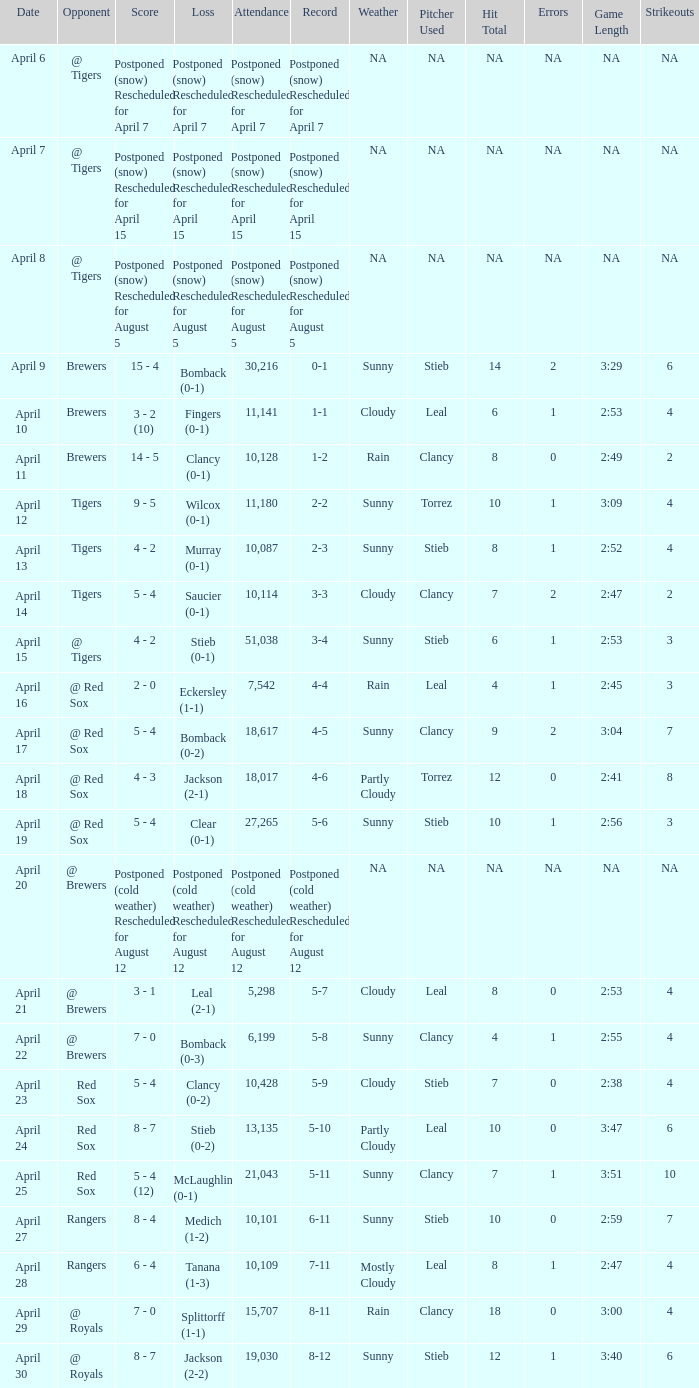What is the score for the game that has an attendance of 5,298? 3 - 1. Write the full table. {'header': ['Date', 'Opponent', 'Score', 'Loss', 'Attendance', 'Record', 'Weather', 'Pitcher Used', 'Hit Total', 'Errors', 'Game Length', 'Strikeouts'], 'rows': [['April 6', '@ Tigers', 'Postponed (snow) Rescheduled for April 7', 'Postponed (snow) Rescheduled for April 7', 'Postponed (snow) Rescheduled for April 7', 'Postponed (snow) Rescheduled for April 7', 'NA', 'NA', 'NA', 'NA', 'NA', 'NA'], ['April 7', '@ Tigers', 'Postponed (snow) Rescheduled for April 15', 'Postponed (snow) Rescheduled for April 15', 'Postponed (snow) Rescheduled for April 15', 'Postponed (snow) Rescheduled for April 15', 'NA', 'NA', 'NA', 'NA', 'NA', 'NA'], ['April 8', '@ Tigers', 'Postponed (snow) Rescheduled for August 5', 'Postponed (snow) Rescheduled for August 5', 'Postponed (snow) Rescheduled for August 5', 'Postponed (snow) Rescheduled for August 5', 'NA', 'NA', 'NA', 'NA', 'NA', 'NA'], ['April 9', 'Brewers', '15 - 4', 'Bomback (0-1)', '30,216', '0-1', 'Sunny', 'Stieb', '14', '2', '3:29', '6'], ['April 10', 'Brewers', '3 - 2 (10)', 'Fingers (0-1)', '11,141', '1-1', 'Cloudy', 'Leal', '6', '1', '2:53', '4'], ['April 11', 'Brewers', '14 - 5', 'Clancy (0-1)', '10,128', '1-2', 'Rain', 'Clancy', '8', '0', '2:49', '2'], ['April 12', 'Tigers', '9 - 5', 'Wilcox (0-1)', '11,180', '2-2', 'Sunny', 'Torrez', '10', '1', '3:09', '4'], ['April 13', 'Tigers', '4 - 2', 'Murray (0-1)', '10,087', '2-3', 'Sunny', 'Stieb', '8', '1', '2:52', '4'], ['April 14', 'Tigers', '5 - 4', 'Saucier (0-1)', '10,114', '3-3', 'Cloudy', 'Clancy', '7', '2', '2:47', '2'], ['April 15', '@ Tigers', '4 - 2', 'Stieb (0-1)', '51,038', '3-4', 'Sunny', 'Stieb', '6', '1', '2:53', '3'], ['April 16', '@ Red Sox', '2 - 0', 'Eckersley (1-1)', '7,542', '4-4', 'Rain', 'Leal', '4', '1', '2:45', '3'], ['April 17', '@ Red Sox', '5 - 4', 'Bomback (0-2)', '18,617', '4-5', 'Sunny', 'Clancy', '9', '2', '3:04', '7'], ['April 18', '@ Red Sox', '4 - 3', 'Jackson (2-1)', '18,017', '4-6', 'Partly Cloudy', 'Torrez', '12', '0', '2:41', '8'], ['April 19', '@ Red Sox', '5 - 4', 'Clear (0-1)', '27,265', '5-6', 'Sunny', 'Stieb', '10', '1', '2:56', '3'], ['April 20', '@ Brewers', 'Postponed (cold weather) Rescheduled for August 12', 'Postponed (cold weather) Rescheduled for August 12', 'Postponed (cold weather) Rescheduled for August 12', 'Postponed (cold weather) Rescheduled for August 12', 'NA', 'NA', 'NA', 'NA', 'NA', 'NA'], ['April 21', '@ Brewers', '3 - 1', 'Leal (2-1)', '5,298', '5-7', 'Cloudy', 'Leal', '8', '0', '2:53', '4'], ['April 22', '@ Brewers', '7 - 0', 'Bomback (0-3)', '6,199', '5-8', 'Sunny', 'Clancy', '4', '1', '2:55', '4'], ['April 23', 'Red Sox', '5 - 4', 'Clancy (0-2)', '10,428', '5-9', 'Cloudy', 'Stieb', '7', '0', '2:38', '4'], ['April 24', 'Red Sox', '8 - 7', 'Stieb (0-2)', '13,135', '5-10', 'Partly Cloudy', 'Leal', '10', '0', '3:47', '6'], ['April 25', 'Red Sox', '5 - 4 (12)', 'McLaughlin (0-1)', '21,043', '5-11', 'Sunny', 'Clancy', '7', '1', '3:51', '10'], ['April 27', 'Rangers', '8 - 4', 'Medich (1-2)', '10,101', '6-11', 'Sunny', 'Stieb', '10', '0', '2:59', '7'], ['April 28', 'Rangers', '6 - 4', 'Tanana (1-3)', '10,109', '7-11', 'Mostly Cloudy', 'Leal', '8', '1', '2:47', '4'], ['April 29', '@ Royals', '7 - 0', 'Splittorff (1-1)', '15,707', '8-11', 'Rain', 'Clancy', '18', '0', '3:00', '4'], ['April 30', '@ Royals', '8 - 7', 'Jackson (2-2)', '19,030', '8-12', 'Sunny', 'Stieb', '12', '1', '3:40', '6']]} 